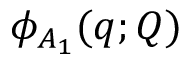<formula> <loc_0><loc_0><loc_500><loc_500>\phi _ { A _ { 1 } } ( q ; Q )</formula> 